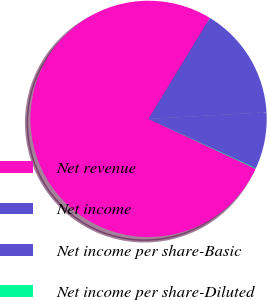Convert chart. <chart><loc_0><loc_0><loc_500><loc_500><pie_chart><fcel>Net revenue<fcel>Net income<fcel>Net income per share-Basic<fcel>Net income per share-Diluted<nl><fcel>76.76%<fcel>15.41%<fcel>7.75%<fcel>0.08%<nl></chart> 